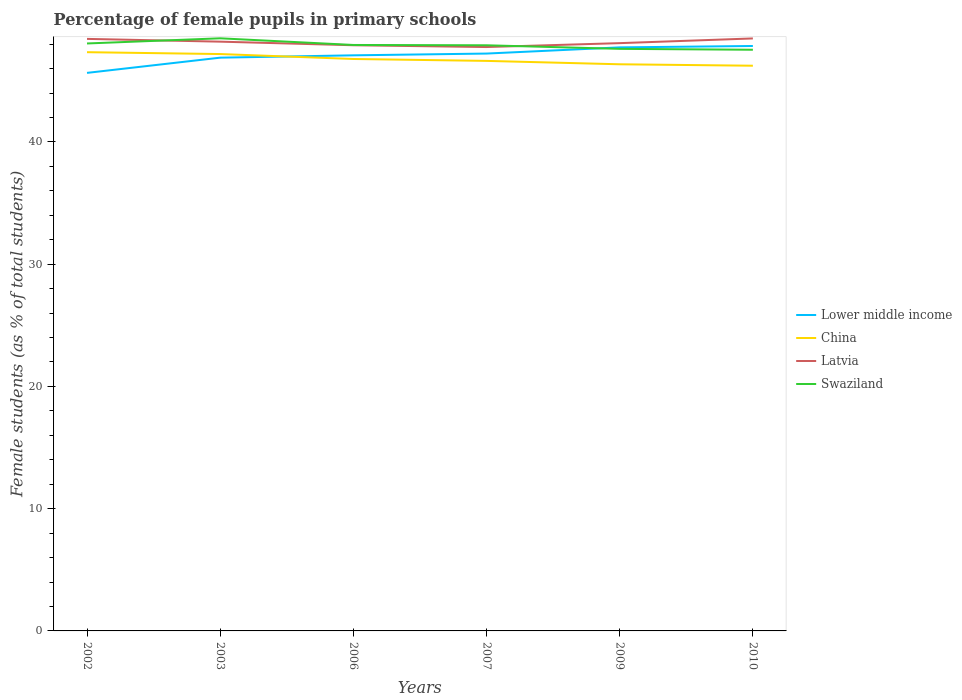How many different coloured lines are there?
Your response must be concise. 4. Does the line corresponding to Lower middle income intersect with the line corresponding to Swaziland?
Offer a very short reply. Yes. Across all years, what is the maximum percentage of female pupils in primary schools in Latvia?
Offer a terse response. 47.76. In which year was the percentage of female pupils in primary schools in China maximum?
Provide a succinct answer. 2010. What is the total percentage of female pupils in primary schools in Swaziland in the graph?
Keep it short and to the point. 0.37. What is the difference between the highest and the second highest percentage of female pupils in primary schools in Latvia?
Give a very brief answer. 0.7. Is the percentage of female pupils in primary schools in Swaziland strictly greater than the percentage of female pupils in primary schools in Lower middle income over the years?
Offer a terse response. No. How many lines are there?
Offer a very short reply. 4. How many years are there in the graph?
Keep it short and to the point. 6. What is the difference between two consecutive major ticks on the Y-axis?
Give a very brief answer. 10. Are the values on the major ticks of Y-axis written in scientific E-notation?
Your answer should be compact. No. Does the graph contain any zero values?
Keep it short and to the point. No. Does the graph contain grids?
Provide a succinct answer. No. What is the title of the graph?
Your answer should be very brief. Percentage of female pupils in primary schools. Does "Paraguay" appear as one of the legend labels in the graph?
Ensure brevity in your answer.  No. What is the label or title of the X-axis?
Make the answer very short. Years. What is the label or title of the Y-axis?
Offer a very short reply. Female students (as % of total students). What is the Female students (as % of total students) in Lower middle income in 2002?
Your response must be concise. 45.65. What is the Female students (as % of total students) in China in 2002?
Ensure brevity in your answer.  47.34. What is the Female students (as % of total students) of Latvia in 2002?
Ensure brevity in your answer.  48.43. What is the Female students (as % of total students) in Swaziland in 2002?
Your answer should be compact. 48.06. What is the Female students (as % of total students) in Lower middle income in 2003?
Provide a short and direct response. 46.9. What is the Female students (as % of total students) of China in 2003?
Your response must be concise. 47.19. What is the Female students (as % of total students) in Latvia in 2003?
Provide a succinct answer. 48.2. What is the Female students (as % of total students) in Swaziland in 2003?
Keep it short and to the point. 48.48. What is the Female students (as % of total students) of Lower middle income in 2006?
Offer a very short reply. 47.09. What is the Female students (as % of total students) of China in 2006?
Keep it short and to the point. 46.79. What is the Female students (as % of total students) in Latvia in 2006?
Provide a succinct answer. 47.91. What is the Female students (as % of total students) in Swaziland in 2006?
Your response must be concise. 47.93. What is the Female students (as % of total students) of Lower middle income in 2007?
Your answer should be very brief. 47.23. What is the Female students (as % of total students) of China in 2007?
Keep it short and to the point. 46.63. What is the Female students (as % of total students) in Latvia in 2007?
Make the answer very short. 47.76. What is the Female students (as % of total students) in Swaziland in 2007?
Ensure brevity in your answer.  47.91. What is the Female students (as % of total students) in Lower middle income in 2009?
Your response must be concise. 47.74. What is the Female students (as % of total students) in China in 2009?
Make the answer very short. 46.35. What is the Female students (as % of total students) of Latvia in 2009?
Keep it short and to the point. 48.08. What is the Female students (as % of total students) in Swaziland in 2009?
Offer a terse response. 47.62. What is the Female students (as % of total students) of Lower middle income in 2010?
Offer a very short reply. 47.85. What is the Female students (as % of total students) in China in 2010?
Offer a very short reply. 46.24. What is the Female students (as % of total students) in Latvia in 2010?
Your answer should be compact. 48.47. What is the Female students (as % of total students) in Swaziland in 2010?
Offer a terse response. 47.54. Across all years, what is the maximum Female students (as % of total students) in Lower middle income?
Give a very brief answer. 47.85. Across all years, what is the maximum Female students (as % of total students) in China?
Make the answer very short. 47.34. Across all years, what is the maximum Female students (as % of total students) of Latvia?
Your answer should be very brief. 48.47. Across all years, what is the maximum Female students (as % of total students) in Swaziland?
Offer a very short reply. 48.48. Across all years, what is the minimum Female students (as % of total students) of Lower middle income?
Make the answer very short. 45.65. Across all years, what is the minimum Female students (as % of total students) of China?
Your response must be concise. 46.24. Across all years, what is the minimum Female students (as % of total students) of Latvia?
Your answer should be compact. 47.76. Across all years, what is the minimum Female students (as % of total students) in Swaziland?
Ensure brevity in your answer.  47.54. What is the total Female students (as % of total students) of Lower middle income in the graph?
Ensure brevity in your answer.  282.45. What is the total Female students (as % of total students) in China in the graph?
Your answer should be compact. 280.54. What is the total Female students (as % of total students) in Latvia in the graph?
Make the answer very short. 288.86. What is the total Female students (as % of total students) in Swaziland in the graph?
Offer a terse response. 287.54. What is the difference between the Female students (as % of total students) in Lower middle income in 2002 and that in 2003?
Make the answer very short. -1.25. What is the difference between the Female students (as % of total students) in China in 2002 and that in 2003?
Offer a terse response. 0.15. What is the difference between the Female students (as % of total students) in Latvia in 2002 and that in 2003?
Provide a short and direct response. 0.23. What is the difference between the Female students (as % of total students) of Swaziland in 2002 and that in 2003?
Offer a very short reply. -0.42. What is the difference between the Female students (as % of total students) of Lower middle income in 2002 and that in 2006?
Provide a short and direct response. -1.44. What is the difference between the Female students (as % of total students) in China in 2002 and that in 2006?
Offer a terse response. 0.56. What is the difference between the Female students (as % of total students) in Latvia in 2002 and that in 2006?
Offer a terse response. 0.52. What is the difference between the Female students (as % of total students) in Swaziland in 2002 and that in 2006?
Keep it short and to the point. 0.12. What is the difference between the Female students (as % of total students) of Lower middle income in 2002 and that in 2007?
Give a very brief answer. -1.58. What is the difference between the Female students (as % of total students) of China in 2002 and that in 2007?
Your answer should be very brief. 0.71. What is the difference between the Female students (as % of total students) of Latvia in 2002 and that in 2007?
Your response must be concise. 0.67. What is the difference between the Female students (as % of total students) in Swaziland in 2002 and that in 2007?
Your answer should be compact. 0.15. What is the difference between the Female students (as % of total students) in Lower middle income in 2002 and that in 2009?
Offer a very short reply. -2.09. What is the difference between the Female students (as % of total students) of Latvia in 2002 and that in 2009?
Offer a terse response. 0.35. What is the difference between the Female students (as % of total students) of Swaziland in 2002 and that in 2009?
Provide a succinct answer. 0.44. What is the difference between the Female students (as % of total students) in Lower middle income in 2002 and that in 2010?
Your response must be concise. -2.2. What is the difference between the Female students (as % of total students) of China in 2002 and that in 2010?
Provide a succinct answer. 1.11. What is the difference between the Female students (as % of total students) in Latvia in 2002 and that in 2010?
Your response must be concise. -0.04. What is the difference between the Female students (as % of total students) of Swaziland in 2002 and that in 2010?
Make the answer very short. 0.51. What is the difference between the Female students (as % of total students) of Lower middle income in 2003 and that in 2006?
Offer a very short reply. -0.19. What is the difference between the Female students (as % of total students) of China in 2003 and that in 2006?
Make the answer very short. 0.4. What is the difference between the Female students (as % of total students) in Latvia in 2003 and that in 2006?
Offer a very short reply. 0.29. What is the difference between the Female students (as % of total students) of Swaziland in 2003 and that in 2006?
Provide a succinct answer. 0.55. What is the difference between the Female students (as % of total students) in Lower middle income in 2003 and that in 2007?
Give a very brief answer. -0.33. What is the difference between the Female students (as % of total students) of China in 2003 and that in 2007?
Your answer should be compact. 0.56. What is the difference between the Female students (as % of total students) in Latvia in 2003 and that in 2007?
Your answer should be compact. 0.44. What is the difference between the Female students (as % of total students) in Swaziland in 2003 and that in 2007?
Offer a terse response. 0.57. What is the difference between the Female students (as % of total students) of Lower middle income in 2003 and that in 2009?
Give a very brief answer. -0.84. What is the difference between the Female students (as % of total students) in China in 2003 and that in 2009?
Your answer should be very brief. 0.84. What is the difference between the Female students (as % of total students) in Latvia in 2003 and that in 2009?
Your response must be concise. 0.12. What is the difference between the Female students (as % of total students) of Swaziland in 2003 and that in 2009?
Make the answer very short. 0.86. What is the difference between the Female students (as % of total students) in Lower middle income in 2003 and that in 2010?
Your answer should be very brief. -0.95. What is the difference between the Female students (as % of total students) of China in 2003 and that in 2010?
Offer a very short reply. 0.95. What is the difference between the Female students (as % of total students) in Latvia in 2003 and that in 2010?
Your answer should be compact. -0.26. What is the difference between the Female students (as % of total students) in Swaziland in 2003 and that in 2010?
Keep it short and to the point. 0.94. What is the difference between the Female students (as % of total students) of Lower middle income in 2006 and that in 2007?
Give a very brief answer. -0.14. What is the difference between the Female students (as % of total students) in China in 2006 and that in 2007?
Your response must be concise. 0.16. What is the difference between the Female students (as % of total students) of Latvia in 2006 and that in 2007?
Make the answer very short. 0.15. What is the difference between the Female students (as % of total students) of Swaziland in 2006 and that in 2007?
Keep it short and to the point. 0.03. What is the difference between the Female students (as % of total students) of Lower middle income in 2006 and that in 2009?
Provide a short and direct response. -0.65. What is the difference between the Female students (as % of total students) in China in 2006 and that in 2009?
Keep it short and to the point. 0.43. What is the difference between the Female students (as % of total students) in Latvia in 2006 and that in 2009?
Give a very brief answer. -0.17. What is the difference between the Female students (as % of total students) in Swaziland in 2006 and that in 2009?
Make the answer very short. 0.32. What is the difference between the Female students (as % of total students) of Lower middle income in 2006 and that in 2010?
Your answer should be compact. -0.76. What is the difference between the Female students (as % of total students) of China in 2006 and that in 2010?
Your answer should be compact. 0.55. What is the difference between the Female students (as % of total students) of Latvia in 2006 and that in 2010?
Ensure brevity in your answer.  -0.56. What is the difference between the Female students (as % of total students) in Swaziland in 2006 and that in 2010?
Offer a very short reply. 0.39. What is the difference between the Female students (as % of total students) of Lower middle income in 2007 and that in 2009?
Provide a short and direct response. -0.51. What is the difference between the Female students (as % of total students) of China in 2007 and that in 2009?
Your response must be concise. 0.28. What is the difference between the Female students (as % of total students) in Latvia in 2007 and that in 2009?
Provide a short and direct response. -0.32. What is the difference between the Female students (as % of total students) in Swaziland in 2007 and that in 2009?
Your answer should be very brief. 0.29. What is the difference between the Female students (as % of total students) in Lower middle income in 2007 and that in 2010?
Give a very brief answer. -0.62. What is the difference between the Female students (as % of total students) of China in 2007 and that in 2010?
Provide a short and direct response. 0.39. What is the difference between the Female students (as % of total students) in Latvia in 2007 and that in 2010?
Keep it short and to the point. -0.7. What is the difference between the Female students (as % of total students) in Swaziland in 2007 and that in 2010?
Your answer should be compact. 0.37. What is the difference between the Female students (as % of total students) in Lower middle income in 2009 and that in 2010?
Your answer should be compact. -0.11. What is the difference between the Female students (as % of total students) of China in 2009 and that in 2010?
Make the answer very short. 0.12. What is the difference between the Female students (as % of total students) of Latvia in 2009 and that in 2010?
Your answer should be very brief. -0.38. What is the difference between the Female students (as % of total students) of Swaziland in 2009 and that in 2010?
Make the answer very short. 0.07. What is the difference between the Female students (as % of total students) of Lower middle income in 2002 and the Female students (as % of total students) of China in 2003?
Provide a short and direct response. -1.54. What is the difference between the Female students (as % of total students) of Lower middle income in 2002 and the Female students (as % of total students) of Latvia in 2003?
Provide a short and direct response. -2.55. What is the difference between the Female students (as % of total students) in Lower middle income in 2002 and the Female students (as % of total students) in Swaziland in 2003?
Keep it short and to the point. -2.83. What is the difference between the Female students (as % of total students) of China in 2002 and the Female students (as % of total students) of Latvia in 2003?
Provide a succinct answer. -0.86. What is the difference between the Female students (as % of total students) of China in 2002 and the Female students (as % of total students) of Swaziland in 2003?
Your answer should be very brief. -1.14. What is the difference between the Female students (as % of total students) of Latvia in 2002 and the Female students (as % of total students) of Swaziland in 2003?
Your answer should be very brief. -0.05. What is the difference between the Female students (as % of total students) of Lower middle income in 2002 and the Female students (as % of total students) of China in 2006?
Your answer should be very brief. -1.14. What is the difference between the Female students (as % of total students) in Lower middle income in 2002 and the Female students (as % of total students) in Latvia in 2006?
Offer a very short reply. -2.26. What is the difference between the Female students (as % of total students) in Lower middle income in 2002 and the Female students (as % of total students) in Swaziland in 2006?
Ensure brevity in your answer.  -2.28. What is the difference between the Female students (as % of total students) of China in 2002 and the Female students (as % of total students) of Latvia in 2006?
Offer a very short reply. -0.57. What is the difference between the Female students (as % of total students) of China in 2002 and the Female students (as % of total students) of Swaziland in 2006?
Offer a terse response. -0.59. What is the difference between the Female students (as % of total students) in Latvia in 2002 and the Female students (as % of total students) in Swaziland in 2006?
Offer a terse response. 0.5. What is the difference between the Female students (as % of total students) of Lower middle income in 2002 and the Female students (as % of total students) of China in 2007?
Offer a very short reply. -0.98. What is the difference between the Female students (as % of total students) of Lower middle income in 2002 and the Female students (as % of total students) of Latvia in 2007?
Provide a short and direct response. -2.11. What is the difference between the Female students (as % of total students) in Lower middle income in 2002 and the Female students (as % of total students) in Swaziland in 2007?
Your response must be concise. -2.26. What is the difference between the Female students (as % of total students) of China in 2002 and the Female students (as % of total students) of Latvia in 2007?
Your answer should be very brief. -0.42. What is the difference between the Female students (as % of total students) of China in 2002 and the Female students (as % of total students) of Swaziland in 2007?
Ensure brevity in your answer.  -0.56. What is the difference between the Female students (as % of total students) in Latvia in 2002 and the Female students (as % of total students) in Swaziland in 2007?
Ensure brevity in your answer.  0.52. What is the difference between the Female students (as % of total students) of Lower middle income in 2002 and the Female students (as % of total students) of China in 2009?
Provide a short and direct response. -0.7. What is the difference between the Female students (as % of total students) of Lower middle income in 2002 and the Female students (as % of total students) of Latvia in 2009?
Your response must be concise. -2.43. What is the difference between the Female students (as % of total students) in Lower middle income in 2002 and the Female students (as % of total students) in Swaziland in 2009?
Provide a short and direct response. -1.97. What is the difference between the Female students (as % of total students) in China in 2002 and the Female students (as % of total students) in Latvia in 2009?
Your response must be concise. -0.74. What is the difference between the Female students (as % of total students) of China in 2002 and the Female students (as % of total students) of Swaziland in 2009?
Ensure brevity in your answer.  -0.27. What is the difference between the Female students (as % of total students) of Latvia in 2002 and the Female students (as % of total students) of Swaziland in 2009?
Offer a terse response. 0.82. What is the difference between the Female students (as % of total students) of Lower middle income in 2002 and the Female students (as % of total students) of China in 2010?
Provide a succinct answer. -0.59. What is the difference between the Female students (as % of total students) of Lower middle income in 2002 and the Female students (as % of total students) of Latvia in 2010?
Your answer should be compact. -2.82. What is the difference between the Female students (as % of total students) of Lower middle income in 2002 and the Female students (as % of total students) of Swaziland in 2010?
Give a very brief answer. -1.89. What is the difference between the Female students (as % of total students) of China in 2002 and the Female students (as % of total students) of Latvia in 2010?
Offer a very short reply. -1.12. What is the difference between the Female students (as % of total students) in China in 2002 and the Female students (as % of total students) in Swaziland in 2010?
Ensure brevity in your answer.  -0.2. What is the difference between the Female students (as % of total students) in Latvia in 2002 and the Female students (as % of total students) in Swaziland in 2010?
Provide a short and direct response. 0.89. What is the difference between the Female students (as % of total students) of Lower middle income in 2003 and the Female students (as % of total students) of China in 2006?
Your answer should be compact. 0.11. What is the difference between the Female students (as % of total students) in Lower middle income in 2003 and the Female students (as % of total students) in Latvia in 2006?
Offer a very short reply. -1.02. What is the difference between the Female students (as % of total students) of Lower middle income in 2003 and the Female students (as % of total students) of Swaziland in 2006?
Your answer should be very brief. -1.04. What is the difference between the Female students (as % of total students) of China in 2003 and the Female students (as % of total students) of Latvia in 2006?
Your answer should be compact. -0.72. What is the difference between the Female students (as % of total students) of China in 2003 and the Female students (as % of total students) of Swaziland in 2006?
Make the answer very short. -0.74. What is the difference between the Female students (as % of total students) of Latvia in 2003 and the Female students (as % of total students) of Swaziland in 2006?
Give a very brief answer. 0.27. What is the difference between the Female students (as % of total students) in Lower middle income in 2003 and the Female students (as % of total students) in China in 2007?
Keep it short and to the point. 0.26. What is the difference between the Female students (as % of total students) in Lower middle income in 2003 and the Female students (as % of total students) in Latvia in 2007?
Give a very brief answer. -0.87. What is the difference between the Female students (as % of total students) of Lower middle income in 2003 and the Female students (as % of total students) of Swaziland in 2007?
Keep it short and to the point. -1.01. What is the difference between the Female students (as % of total students) of China in 2003 and the Female students (as % of total students) of Latvia in 2007?
Your response must be concise. -0.57. What is the difference between the Female students (as % of total students) of China in 2003 and the Female students (as % of total students) of Swaziland in 2007?
Give a very brief answer. -0.72. What is the difference between the Female students (as % of total students) of Latvia in 2003 and the Female students (as % of total students) of Swaziland in 2007?
Keep it short and to the point. 0.3. What is the difference between the Female students (as % of total students) in Lower middle income in 2003 and the Female students (as % of total students) in China in 2009?
Keep it short and to the point. 0.54. What is the difference between the Female students (as % of total students) in Lower middle income in 2003 and the Female students (as % of total students) in Latvia in 2009?
Offer a terse response. -1.19. What is the difference between the Female students (as % of total students) of Lower middle income in 2003 and the Female students (as % of total students) of Swaziland in 2009?
Your response must be concise. -0.72. What is the difference between the Female students (as % of total students) of China in 2003 and the Female students (as % of total students) of Latvia in 2009?
Provide a short and direct response. -0.89. What is the difference between the Female students (as % of total students) in China in 2003 and the Female students (as % of total students) in Swaziland in 2009?
Offer a very short reply. -0.43. What is the difference between the Female students (as % of total students) in Latvia in 2003 and the Female students (as % of total students) in Swaziland in 2009?
Offer a terse response. 0.59. What is the difference between the Female students (as % of total students) of Lower middle income in 2003 and the Female students (as % of total students) of China in 2010?
Offer a very short reply. 0.66. What is the difference between the Female students (as % of total students) of Lower middle income in 2003 and the Female students (as % of total students) of Latvia in 2010?
Offer a terse response. -1.57. What is the difference between the Female students (as % of total students) in Lower middle income in 2003 and the Female students (as % of total students) in Swaziland in 2010?
Keep it short and to the point. -0.65. What is the difference between the Female students (as % of total students) in China in 2003 and the Female students (as % of total students) in Latvia in 2010?
Provide a short and direct response. -1.28. What is the difference between the Female students (as % of total students) in China in 2003 and the Female students (as % of total students) in Swaziland in 2010?
Your answer should be compact. -0.35. What is the difference between the Female students (as % of total students) in Latvia in 2003 and the Female students (as % of total students) in Swaziland in 2010?
Ensure brevity in your answer.  0.66. What is the difference between the Female students (as % of total students) in Lower middle income in 2006 and the Female students (as % of total students) in China in 2007?
Provide a short and direct response. 0.46. What is the difference between the Female students (as % of total students) of Lower middle income in 2006 and the Female students (as % of total students) of Latvia in 2007?
Provide a succinct answer. -0.68. What is the difference between the Female students (as % of total students) of Lower middle income in 2006 and the Female students (as % of total students) of Swaziland in 2007?
Provide a short and direct response. -0.82. What is the difference between the Female students (as % of total students) of China in 2006 and the Female students (as % of total students) of Latvia in 2007?
Keep it short and to the point. -0.98. What is the difference between the Female students (as % of total students) of China in 2006 and the Female students (as % of total students) of Swaziland in 2007?
Provide a short and direct response. -1.12. What is the difference between the Female students (as % of total students) in Latvia in 2006 and the Female students (as % of total students) in Swaziland in 2007?
Offer a terse response. 0. What is the difference between the Female students (as % of total students) of Lower middle income in 2006 and the Female students (as % of total students) of China in 2009?
Give a very brief answer. 0.73. What is the difference between the Female students (as % of total students) of Lower middle income in 2006 and the Female students (as % of total students) of Latvia in 2009?
Your response must be concise. -1. What is the difference between the Female students (as % of total students) of Lower middle income in 2006 and the Female students (as % of total students) of Swaziland in 2009?
Offer a very short reply. -0.53. What is the difference between the Female students (as % of total students) in China in 2006 and the Female students (as % of total students) in Latvia in 2009?
Offer a very short reply. -1.3. What is the difference between the Female students (as % of total students) in China in 2006 and the Female students (as % of total students) in Swaziland in 2009?
Provide a short and direct response. -0.83. What is the difference between the Female students (as % of total students) in Latvia in 2006 and the Female students (as % of total students) in Swaziland in 2009?
Offer a very short reply. 0.29. What is the difference between the Female students (as % of total students) in Lower middle income in 2006 and the Female students (as % of total students) in China in 2010?
Offer a very short reply. 0.85. What is the difference between the Female students (as % of total students) of Lower middle income in 2006 and the Female students (as % of total students) of Latvia in 2010?
Provide a short and direct response. -1.38. What is the difference between the Female students (as % of total students) in Lower middle income in 2006 and the Female students (as % of total students) in Swaziland in 2010?
Offer a terse response. -0.46. What is the difference between the Female students (as % of total students) in China in 2006 and the Female students (as % of total students) in Latvia in 2010?
Your answer should be compact. -1.68. What is the difference between the Female students (as % of total students) of China in 2006 and the Female students (as % of total students) of Swaziland in 2010?
Offer a very short reply. -0.75. What is the difference between the Female students (as % of total students) in Latvia in 2006 and the Female students (as % of total students) in Swaziland in 2010?
Offer a terse response. 0.37. What is the difference between the Female students (as % of total students) of Lower middle income in 2007 and the Female students (as % of total students) of China in 2009?
Provide a succinct answer. 0.88. What is the difference between the Female students (as % of total students) in Lower middle income in 2007 and the Female students (as % of total students) in Latvia in 2009?
Give a very brief answer. -0.85. What is the difference between the Female students (as % of total students) in Lower middle income in 2007 and the Female students (as % of total students) in Swaziland in 2009?
Offer a terse response. -0.39. What is the difference between the Female students (as % of total students) of China in 2007 and the Female students (as % of total students) of Latvia in 2009?
Provide a short and direct response. -1.45. What is the difference between the Female students (as % of total students) of China in 2007 and the Female students (as % of total students) of Swaziland in 2009?
Your answer should be very brief. -0.98. What is the difference between the Female students (as % of total students) in Latvia in 2007 and the Female students (as % of total students) in Swaziland in 2009?
Provide a succinct answer. 0.15. What is the difference between the Female students (as % of total students) of Lower middle income in 2007 and the Female students (as % of total students) of China in 2010?
Your response must be concise. 0.99. What is the difference between the Female students (as % of total students) of Lower middle income in 2007 and the Female students (as % of total students) of Latvia in 2010?
Your answer should be very brief. -1.24. What is the difference between the Female students (as % of total students) of Lower middle income in 2007 and the Female students (as % of total students) of Swaziland in 2010?
Keep it short and to the point. -0.31. What is the difference between the Female students (as % of total students) in China in 2007 and the Female students (as % of total students) in Latvia in 2010?
Offer a terse response. -1.84. What is the difference between the Female students (as % of total students) of China in 2007 and the Female students (as % of total students) of Swaziland in 2010?
Keep it short and to the point. -0.91. What is the difference between the Female students (as % of total students) of Latvia in 2007 and the Female students (as % of total students) of Swaziland in 2010?
Offer a very short reply. 0.22. What is the difference between the Female students (as % of total students) in Lower middle income in 2009 and the Female students (as % of total students) in China in 2010?
Provide a short and direct response. 1.5. What is the difference between the Female students (as % of total students) of Lower middle income in 2009 and the Female students (as % of total students) of Latvia in 2010?
Make the answer very short. -0.73. What is the difference between the Female students (as % of total students) of Lower middle income in 2009 and the Female students (as % of total students) of Swaziland in 2010?
Ensure brevity in your answer.  0.19. What is the difference between the Female students (as % of total students) in China in 2009 and the Female students (as % of total students) in Latvia in 2010?
Your response must be concise. -2.11. What is the difference between the Female students (as % of total students) in China in 2009 and the Female students (as % of total students) in Swaziland in 2010?
Your response must be concise. -1.19. What is the difference between the Female students (as % of total students) of Latvia in 2009 and the Female students (as % of total students) of Swaziland in 2010?
Your response must be concise. 0.54. What is the average Female students (as % of total students) of Lower middle income per year?
Your answer should be very brief. 47.08. What is the average Female students (as % of total students) in China per year?
Give a very brief answer. 46.76. What is the average Female students (as % of total students) in Latvia per year?
Provide a short and direct response. 48.14. What is the average Female students (as % of total students) of Swaziland per year?
Offer a terse response. 47.92. In the year 2002, what is the difference between the Female students (as % of total students) in Lower middle income and Female students (as % of total students) in China?
Offer a very short reply. -1.69. In the year 2002, what is the difference between the Female students (as % of total students) of Lower middle income and Female students (as % of total students) of Latvia?
Ensure brevity in your answer.  -2.78. In the year 2002, what is the difference between the Female students (as % of total students) of Lower middle income and Female students (as % of total students) of Swaziland?
Make the answer very short. -2.41. In the year 2002, what is the difference between the Female students (as % of total students) of China and Female students (as % of total students) of Latvia?
Ensure brevity in your answer.  -1.09. In the year 2002, what is the difference between the Female students (as % of total students) of China and Female students (as % of total students) of Swaziland?
Provide a succinct answer. -0.71. In the year 2002, what is the difference between the Female students (as % of total students) in Latvia and Female students (as % of total students) in Swaziland?
Make the answer very short. 0.38. In the year 2003, what is the difference between the Female students (as % of total students) of Lower middle income and Female students (as % of total students) of China?
Provide a succinct answer. -0.3. In the year 2003, what is the difference between the Female students (as % of total students) in Lower middle income and Female students (as % of total students) in Latvia?
Your answer should be very brief. -1.31. In the year 2003, what is the difference between the Female students (as % of total students) in Lower middle income and Female students (as % of total students) in Swaziland?
Keep it short and to the point. -1.58. In the year 2003, what is the difference between the Female students (as % of total students) in China and Female students (as % of total students) in Latvia?
Keep it short and to the point. -1.01. In the year 2003, what is the difference between the Female students (as % of total students) of China and Female students (as % of total students) of Swaziland?
Offer a very short reply. -1.29. In the year 2003, what is the difference between the Female students (as % of total students) in Latvia and Female students (as % of total students) in Swaziland?
Your response must be concise. -0.27. In the year 2006, what is the difference between the Female students (as % of total students) of Lower middle income and Female students (as % of total students) of China?
Give a very brief answer. 0.3. In the year 2006, what is the difference between the Female students (as % of total students) in Lower middle income and Female students (as % of total students) in Latvia?
Provide a succinct answer. -0.82. In the year 2006, what is the difference between the Female students (as % of total students) of Lower middle income and Female students (as % of total students) of Swaziland?
Provide a short and direct response. -0.85. In the year 2006, what is the difference between the Female students (as % of total students) in China and Female students (as % of total students) in Latvia?
Offer a very short reply. -1.12. In the year 2006, what is the difference between the Female students (as % of total students) in China and Female students (as % of total students) in Swaziland?
Keep it short and to the point. -1.15. In the year 2006, what is the difference between the Female students (as % of total students) in Latvia and Female students (as % of total students) in Swaziland?
Your response must be concise. -0.02. In the year 2007, what is the difference between the Female students (as % of total students) of Lower middle income and Female students (as % of total students) of China?
Give a very brief answer. 0.6. In the year 2007, what is the difference between the Female students (as % of total students) of Lower middle income and Female students (as % of total students) of Latvia?
Offer a very short reply. -0.53. In the year 2007, what is the difference between the Female students (as % of total students) in Lower middle income and Female students (as % of total students) in Swaziland?
Make the answer very short. -0.68. In the year 2007, what is the difference between the Female students (as % of total students) in China and Female students (as % of total students) in Latvia?
Your response must be concise. -1.13. In the year 2007, what is the difference between the Female students (as % of total students) of China and Female students (as % of total students) of Swaziland?
Offer a terse response. -1.28. In the year 2007, what is the difference between the Female students (as % of total students) of Latvia and Female students (as % of total students) of Swaziland?
Make the answer very short. -0.14. In the year 2009, what is the difference between the Female students (as % of total students) of Lower middle income and Female students (as % of total students) of China?
Your answer should be very brief. 1.38. In the year 2009, what is the difference between the Female students (as % of total students) of Lower middle income and Female students (as % of total students) of Latvia?
Your answer should be very brief. -0.35. In the year 2009, what is the difference between the Female students (as % of total students) of Lower middle income and Female students (as % of total students) of Swaziland?
Make the answer very short. 0.12. In the year 2009, what is the difference between the Female students (as % of total students) of China and Female students (as % of total students) of Latvia?
Offer a very short reply. -1.73. In the year 2009, what is the difference between the Female students (as % of total students) in China and Female students (as % of total students) in Swaziland?
Your answer should be compact. -1.26. In the year 2009, what is the difference between the Female students (as % of total students) in Latvia and Female students (as % of total students) in Swaziland?
Keep it short and to the point. 0.47. In the year 2010, what is the difference between the Female students (as % of total students) in Lower middle income and Female students (as % of total students) in China?
Provide a short and direct response. 1.61. In the year 2010, what is the difference between the Female students (as % of total students) of Lower middle income and Female students (as % of total students) of Latvia?
Give a very brief answer. -0.62. In the year 2010, what is the difference between the Female students (as % of total students) of Lower middle income and Female students (as % of total students) of Swaziland?
Make the answer very short. 0.31. In the year 2010, what is the difference between the Female students (as % of total students) of China and Female students (as % of total students) of Latvia?
Keep it short and to the point. -2.23. In the year 2010, what is the difference between the Female students (as % of total students) in China and Female students (as % of total students) in Swaziland?
Provide a short and direct response. -1.31. In the year 2010, what is the difference between the Female students (as % of total students) in Latvia and Female students (as % of total students) in Swaziland?
Offer a very short reply. 0.93. What is the ratio of the Female students (as % of total students) of Lower middle income in 2002 to that in 2003?
Your answer should be very brief. 0.97. What is the ratio of the Female students (as % of total students) of Lower middle income in 2002 to that in 2006?
Your answer should be compact. 0.97. What is the ratio of the Female students (as % of total students) of China in 2002 to that in 2006?
Offer a terse response. 1.01. What is the ratio of the Female students (as % of total students) of Latvia in 2002 to that in 2006?
Your answer should be very brief. 1.01. What is the ratio of the Female students (as % of total students) in Swaziland in 2002 to that in 2006?
Give a very brief answer. 1. What is the ratio of the Female students (as % of total students) in Lower middle income in 2002 to that in 2007?
Ensure brevity in your answer.  0.97. What is the ratio of the Female students (as % of total students) in China in 2002 to that in 2007?
Offer a terse response. 1.02. What is the ratio of the Female students (as % of total students) of Latvia in 2002 to that in 2007?
Give a very brief answer. 1.01. What is the ratio of the Female students (as % of total students) in Swaziland in 2002 to that in 2007?
Provide a short and direct response. 1. What is the ratio of the Female students (as % of total students) in Lower middle income in 2002 to that in 2009?
Offer a very short reply. 0.96. What is the ratio of the Female students (as % of total students) of China in 2002 to that in 2009?
Make the answer very short. 1.02. What is the ratio of the Female students (as % of total students) in Swaziland in 2002 to that in 2009?
Ensure brevity in your answer.  1.01. What is the ratio of the Female students (as % of total students) in Lower middle income in 2002 to that in 2010?
Offer a very short reply. 0.95. What is the ratio of the Female students (as % of total students) in China in 2002 to that in 2010?
Make the answer very short. 1.02. What is the ratio of the Female students (as % of total students) of Latvia in 2002 to that in 2010?
Your answer should be very brief. 1. What is the ratio of the Female students (as % of total students) of Swaziland in 2002 to that in 2010?
Provide a succinct answer. 1.01. What is the ratio of the Female students (as % of total students) of China in 2003 to that in 2006?
Provide a succinct answer. 1.01. What is the ratio of the Female students (as % of total students) of Latvia in 2003 to that in 2006?
Provide a short and direct response. 1.01. What is the ratio of the Female students (as % of total students) of Swaziland in 2003 to that in 2006?
Offer a terse response. 1.01. What is the ratio of the Female students (as % of total students) of China in 2003 to that in 2007?
Offer a very short reply. 1.01. What is the ratio of the Female students (as % of total students) of Latvia in 2003 to that in 2007?
Provide a short and direct response. 1.01. What is the ratio of the Female students (as % of total students) of Swaziland in 2003 to that in 2007?
Ensure brevity in your answer.  1.01. What is the ratio of the Female students (as % of total students) of Lower middle income in 2003 to that in 2009?
Your response must be concise. 0.98. What is the ratio of the Female students (as % of total students) of China in 2003 to that in 2009?
Your answer should be compact. 1.02. What is the ratio of the Female students (as % of total students) in Latvia in 2003 to that in 2009?
Provide a succinct answer. 1. What is the ratio of the Female students (as % of total students) in Swaziland in 2003 to that in 2009?
Your answer should be compact. 1.02. What is the ratio of the Female students (as % of total students) of China in 2003 to that in 2010?
Keep it short and to the point. 1.02. What is the ratio of the Female students (as % of total students) of Latvia in 2003 to that in 2010?
Provide a short and direct response. 0.99. What is the ratio of the Female students (as % of total students) in Swaziland in 2003 to that in 2010?
Your answer should be very brief. 1.02. What is the ratio of the Female students (as % of total students) in Swaziland in 2006 to that in 2007?
Ensure brevity in your answer.  1. What is the ratio of the Female students (as % of total students) of Lower middle income in 2006 to that in 2009?
Make the answer very short. 0.99. What is the ratio of the Female students (as % of total students) of China in 2006 to that in 2009?
Make the answer very short. 1.01. What is the ratio of the Female students (as % of total students) of Swaziland in 2006 to that in 2009?
Offer a very short reply. 1.01. What is the ratio of the Female students (as % of total students) in Lower middle income in 2006 to that in 2010?
Make the answer very short. 0.98. What is the ratio of the Female students (as % of total students) in China in 2006 to that in 2010?
Keep it short and to the point. 1.01. What is the ratio of the Female students (as % of total students) in Latvia in 2006 to that in 2010?
Keep it short and to the point. 0.99. What is the ratio of the Female students (as % of total students) in Swaziland in 2006 to that in 2010?
Your answer should be very brief. 1.01. What is the ratio of the Female students (as % of total students) in China in 2007 to that in 2009?
Give a very brief answer. 1.01. What is the ratio of the Female students (as % of total students) of Lower middle income in 2007 to that in 2010?
Offer a terse response. 0.99. What is the ratio of the Female students (as % of total students) of China in 2007 to that in 2010?
Your response must be concise. 1.01. What is the ratio of the Female students (as % of total students) of Latvia in 2007 to that in 2010?
Offer a terse response. 0.99. What is the ratio of the Female students (as % of total students) in Swaziland in 2007 to that in 2010?
Ensure brevity in your answer.  1.01. What is the ratio of the Female students (as % of total students) in China in 2009 to that in 2010?
Offer a terse response. 1. What is the ratio of the Female students (as % of total students) of Latvia in 2009 to that in 2010?
Your response must be concise. 0.99. What is the ratio of the Female students (as % of total students) in Swaziland in 2009 to that in 2010?
Offer a very short reply. 1. What is the difference between the highest and the second highest Female students (as % of total students) of Lower middle income?
Your answer should be compact. 0.11. What is the difference between the highest and the second highest Female students (as % of total students) of China?
Offer a terse response. 0.15. What is the difference between the highest and the second highest Female students (as % of total students) of Latvia?
Your answer should be very brief. 0.04. What is the difference between the highest and the second highest Female students (as % of total students) in Swaziland?
Your answer should be very brief. 0.42. What is the difference between the highest and the lowest Female students (as % of total students) in Lower middle income?
Ensure brevity in your answer.  2.2. What is the difference between the highest and the lowest Female students (as % of total students) of China?
Your answer should be very brief. 1.11. What is the difference between the highest and the lowest Female students (as % of total students) in Latvia?
Give a very brief answer. 0.7. What is the difference between the highest and the lowest Female students (as % of total students) of Swaziland?
Make the answer very short. 0.94. 